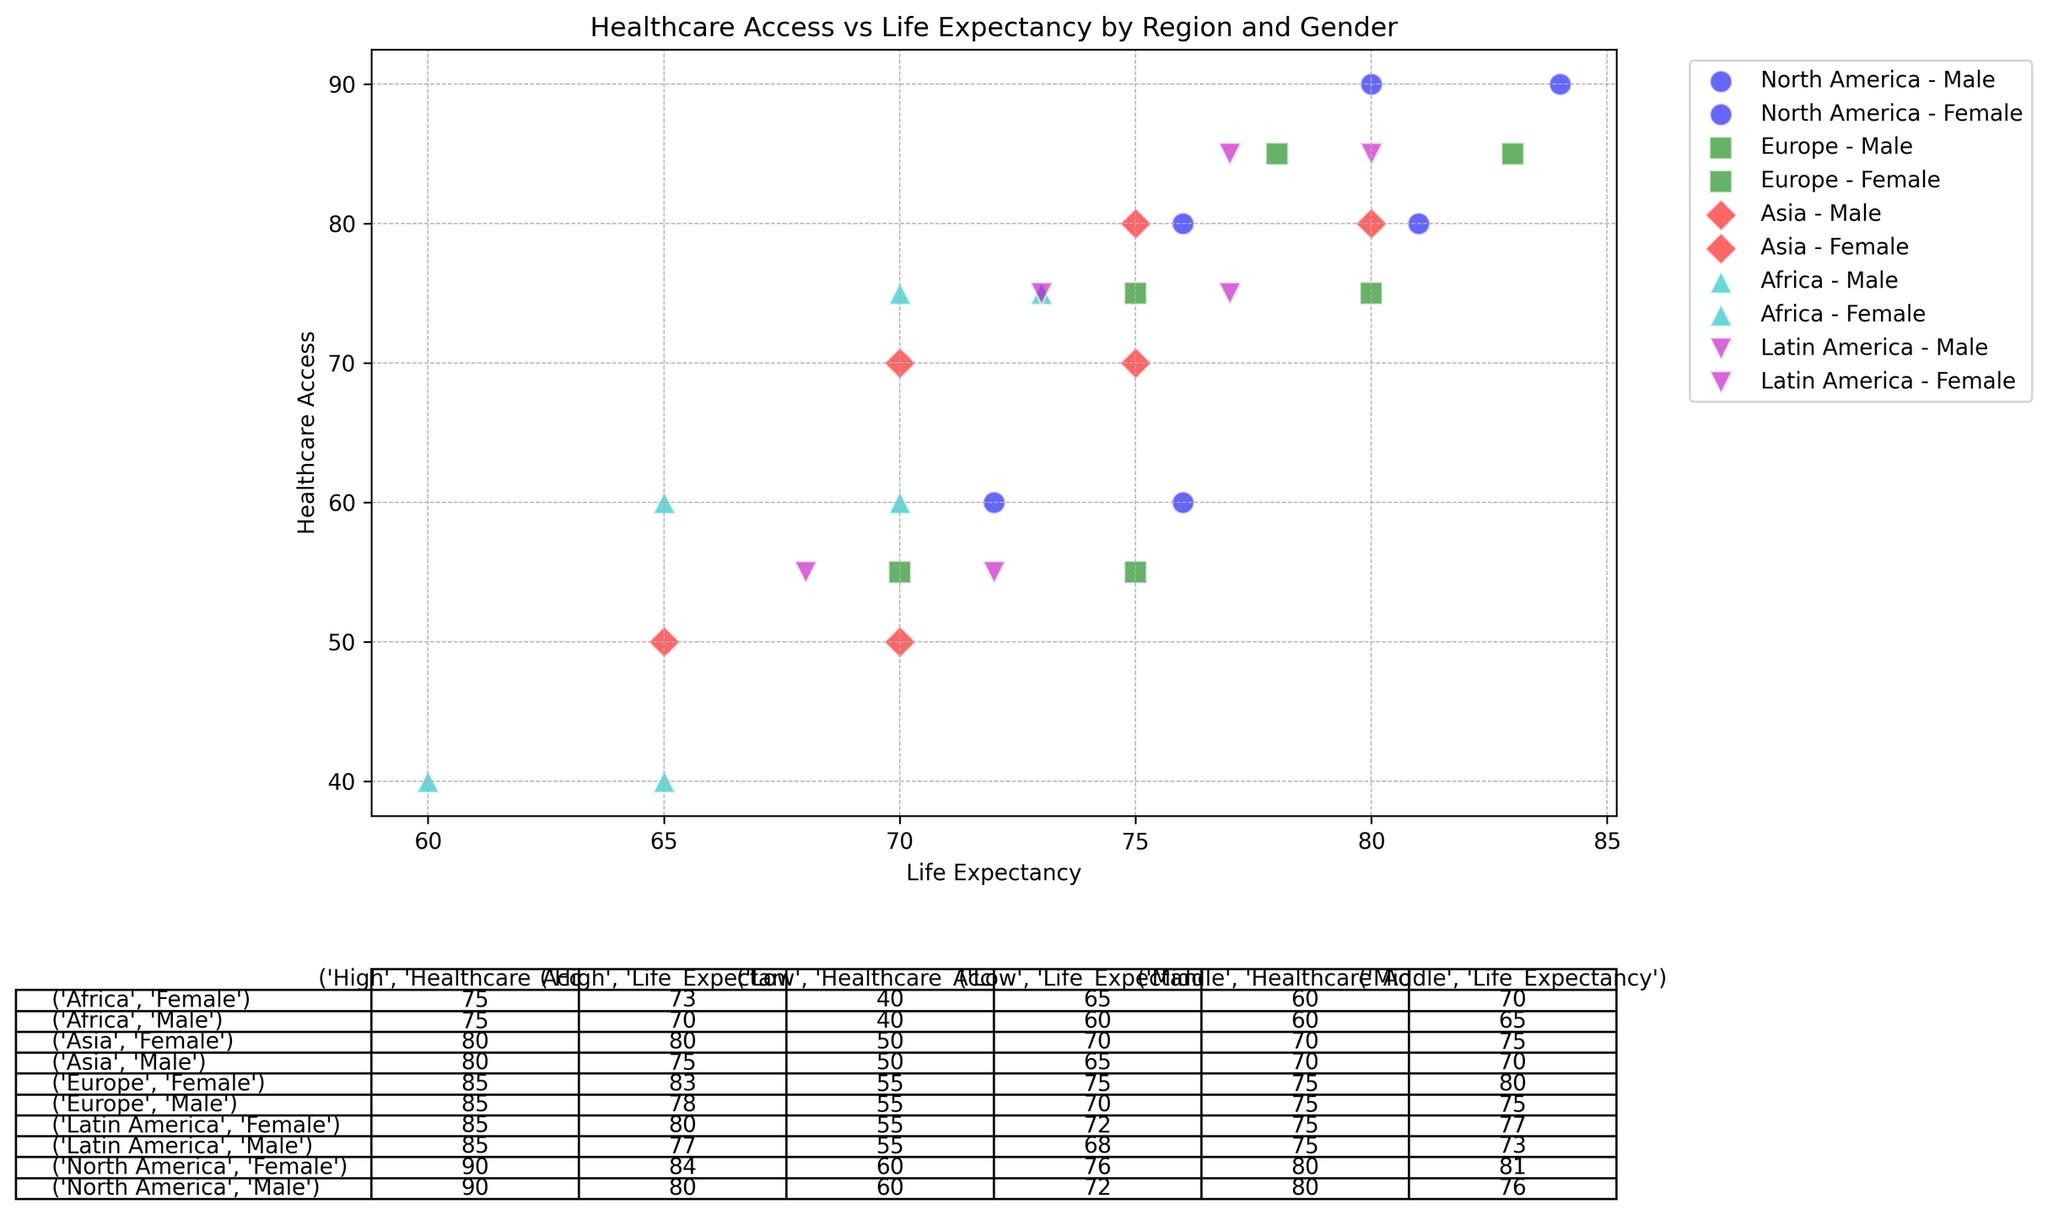What's the highest life expectancy value observed in North America for females? To find the highest life expectancy value for North American females, look at the table data for North America under the female category. The highest life expectancy value listed is 84.
Answer: 84 What is the difference in healthcare access between high-income males and low-income males in Latin America? To find the difference in healthcare access, subtract the healthcare access value of low-income males (55) from that of high-income males (85) in Latin America. The calculation is 85 - 55 = 30.
Answer: 30 Which region has the lowest healthcare access for females in the low-income category? Check the healthcare access values for females in the low-income category for all regions. Africa has the lowest value with 40.
Answer: Africa Compare the life expectancy of middle-income males in North America and Europe. Which one is higher? Look at the life expectancy values for middle-income males in both regions. North America has 76, and Europe has 75. Since 76 is higher, the middle-income males in North America have a higher life expectancy.
Answer: North America What is the average healthcare access for high-income individuals in Asia? First, find the healthcare access values for high-income males and females in Asia, which are both 80. The average is calculated by (80 + 80) / 2 = 80.
Answer: 80 How does the life expectancy of high-income females compare across all regions? Compare the life expectancy values of high-income females across North America (84), Europe (83), Asia (80), Africa (73), and Latin America (80). North America has the highest value with 84.
Answer: North America Between middle-income males and females in Europe, who has better healthcare access? Compare the healthcare access values for middle-income males (75) and females (75) in Europe. Both have the same value of 75.
Answer: Both are equal Calculate the total sum of healthcare access values for low-income individuals in Africa. The healthcare access values for low-income males and females in Africa are both 40. The total sum is calculated by adding these values together: 40 + 40 = 80.
Answer: 80 What's the difference in life expectancy between low-income males and high-income females in Asia? Subtract the life expectancy of low-income males (65) from that of high-income females (80) in Asia. The calculation is 80 - 65 = 15.
Answer: 15 